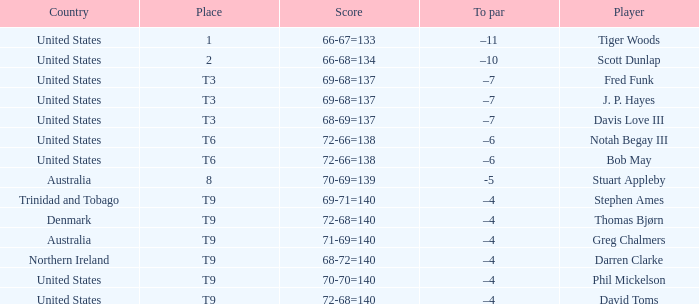What country is Stephen Ames from with a place value of t9? Trinidad and Tobago. 